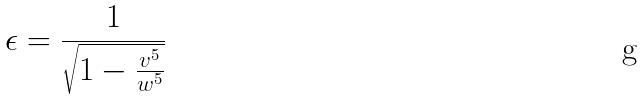Convert formula to latex. <formula><loc_0><loc_0><loc_500><loc_500>\epsilon = \frac { 1 } { \sqrt { 1 - \frac { v ^ { 5 } } { w ^ { 5 } } } }</formula> 